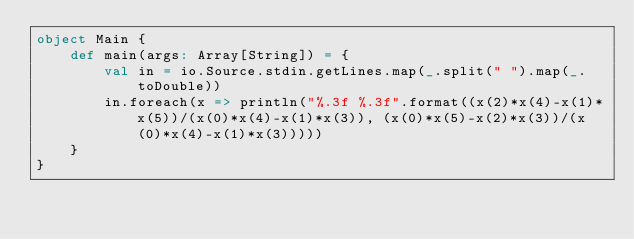<code> <loc_0><loc_0><loc_500><loc_500><_Scala_>object Main {
    def main(args: Array[String]) = {
        val in = io.Source.stdin.getLines.map(_.split(" ").map(_.toDouble))
        in.foreach(x => println("%.3f %.3f".format((x(2)*x(4)-x(1)*x(5))/(x(0)*x(4)-x(1)*x(3)), (x(0)*x(5)-x(2)*x(3))/(x(0)*x(4)-x(1)*x(3)))))
    }
}</code> 